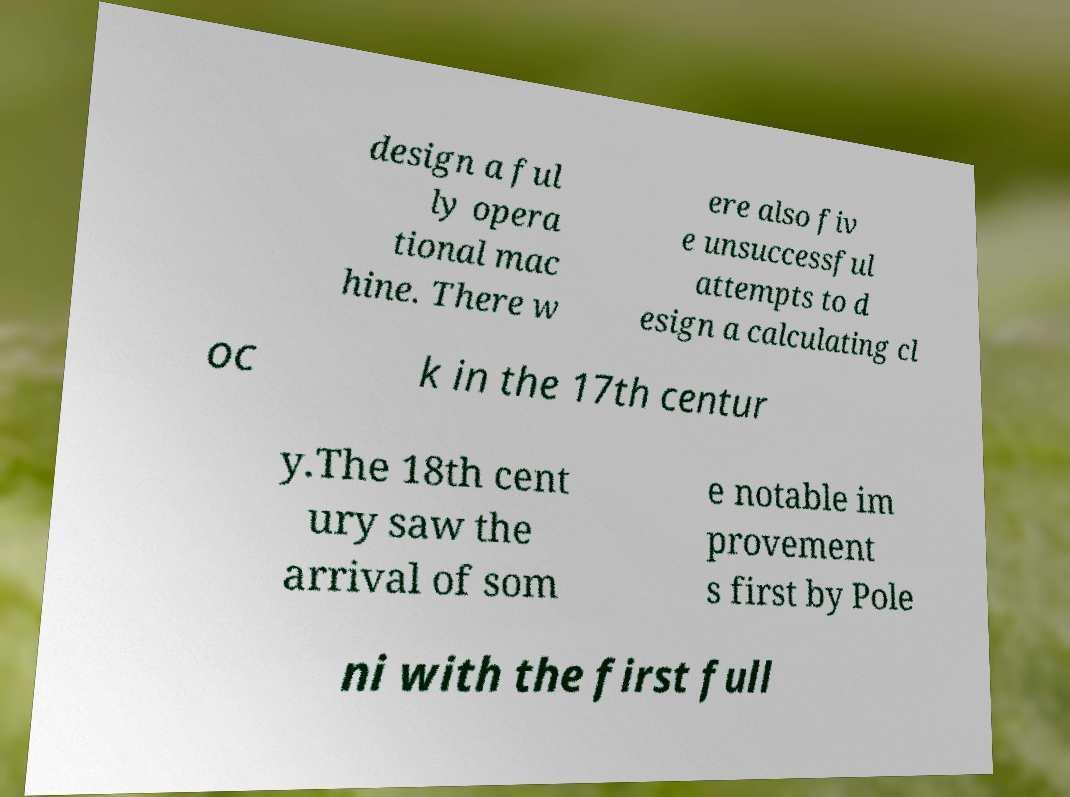Can you accurately transcribe the text from the provided image for me? design a ful ly opera tional mac hine. There w ere also fiv e unsuccessful attempts to d esign a calculating cl oc k in the 17th centur y.The 18th cent ury saw the arrival of som e notable im provement s first by Pole ni with the first full 